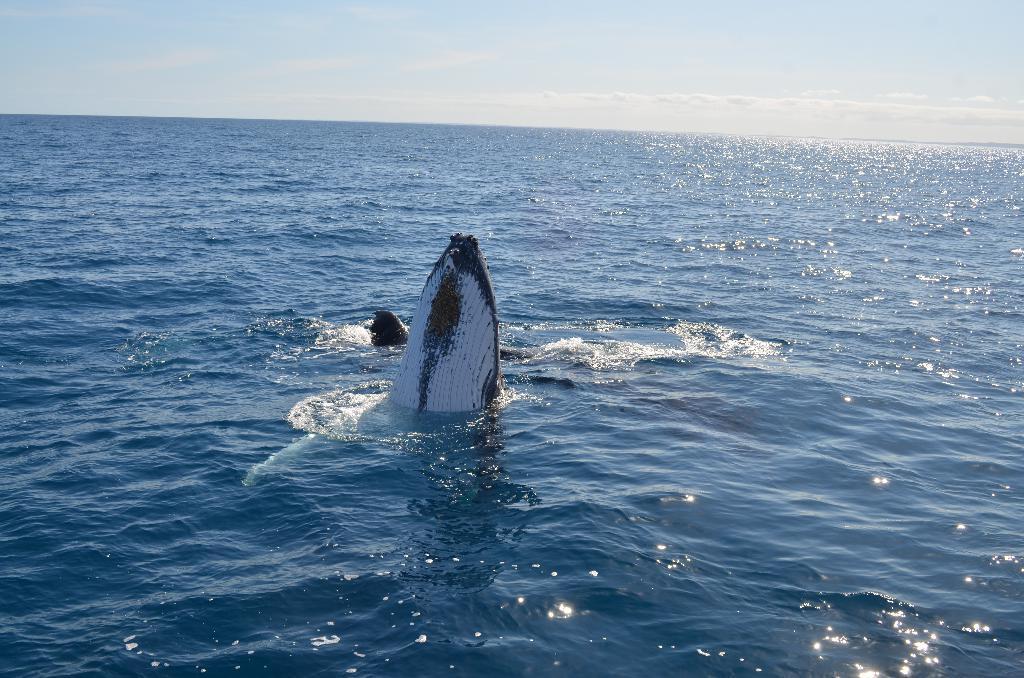Please provide a concise description of this image. In this I can see the ocean ,at the top I can see the sky and in the ocean I can see an animal 